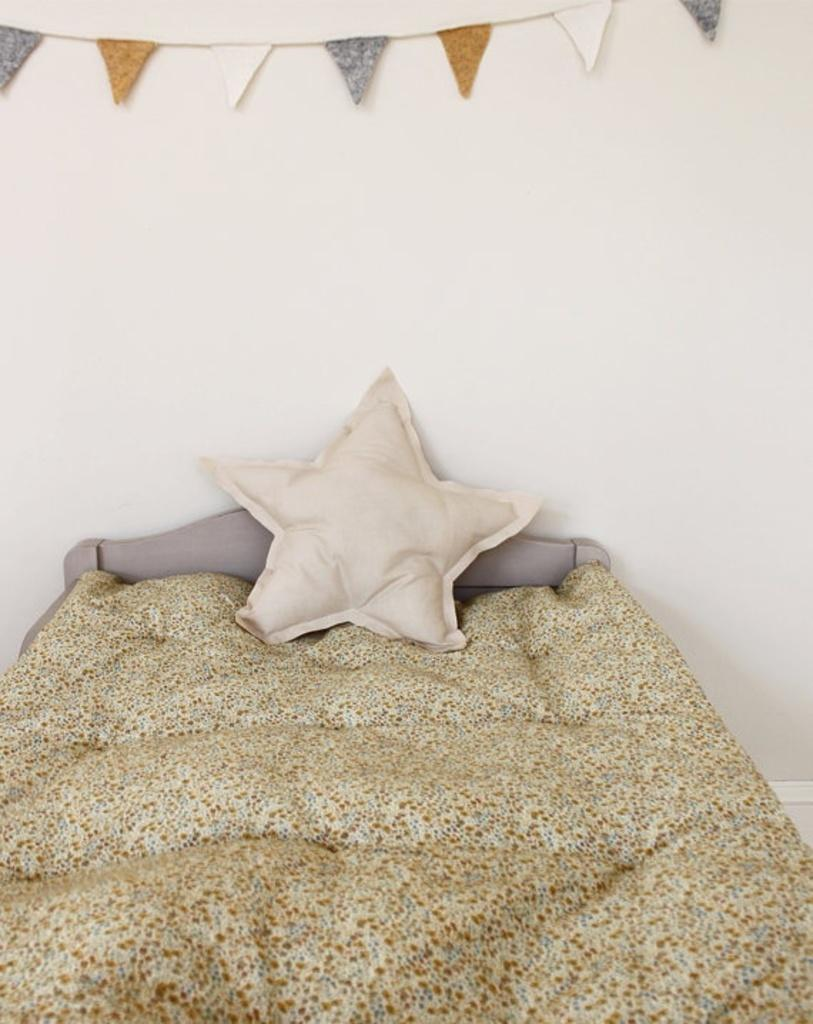What piece of furniture is present in the image? There is a bed in the image. What color is the pillow on the bed? The pillow on the bed is white. What color is the blanket on the bed? The blanket on the bed is white. What color is the wall in the background of the image? The wall in the background of the image is white. What can be seen in the background of the image besides the wall? There are some objects visible in the background of the image. What type of tax is being discussed in the image? There is no discussion of tax in the image; it features a bed with white pillow and blanket, and a white wall in the background. How many cacti are visible in the image? There are no cacti present in the image. 